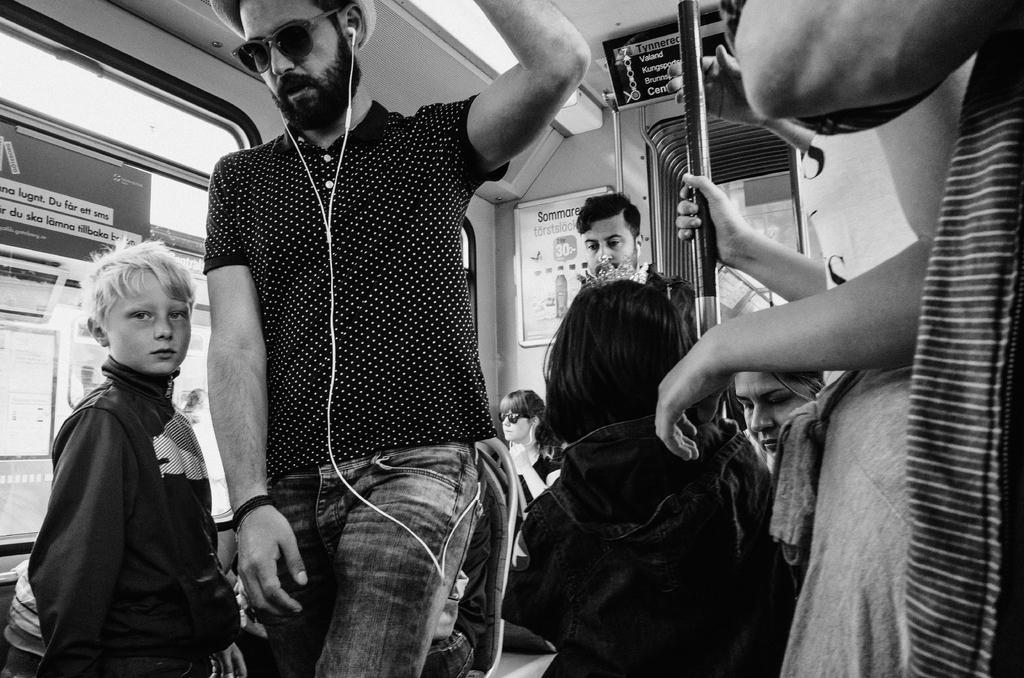Could you give a brief overview of what you see in this image? In the center of the image a man is standing and wearing goggles, hat and headset. On the left side of the image a boy is standing. On the right side of the image some persons are standing. In the middle of the image a pole is there. On the left side of the image window is present. Some persons are sitting on a chair in the middle of the image. 